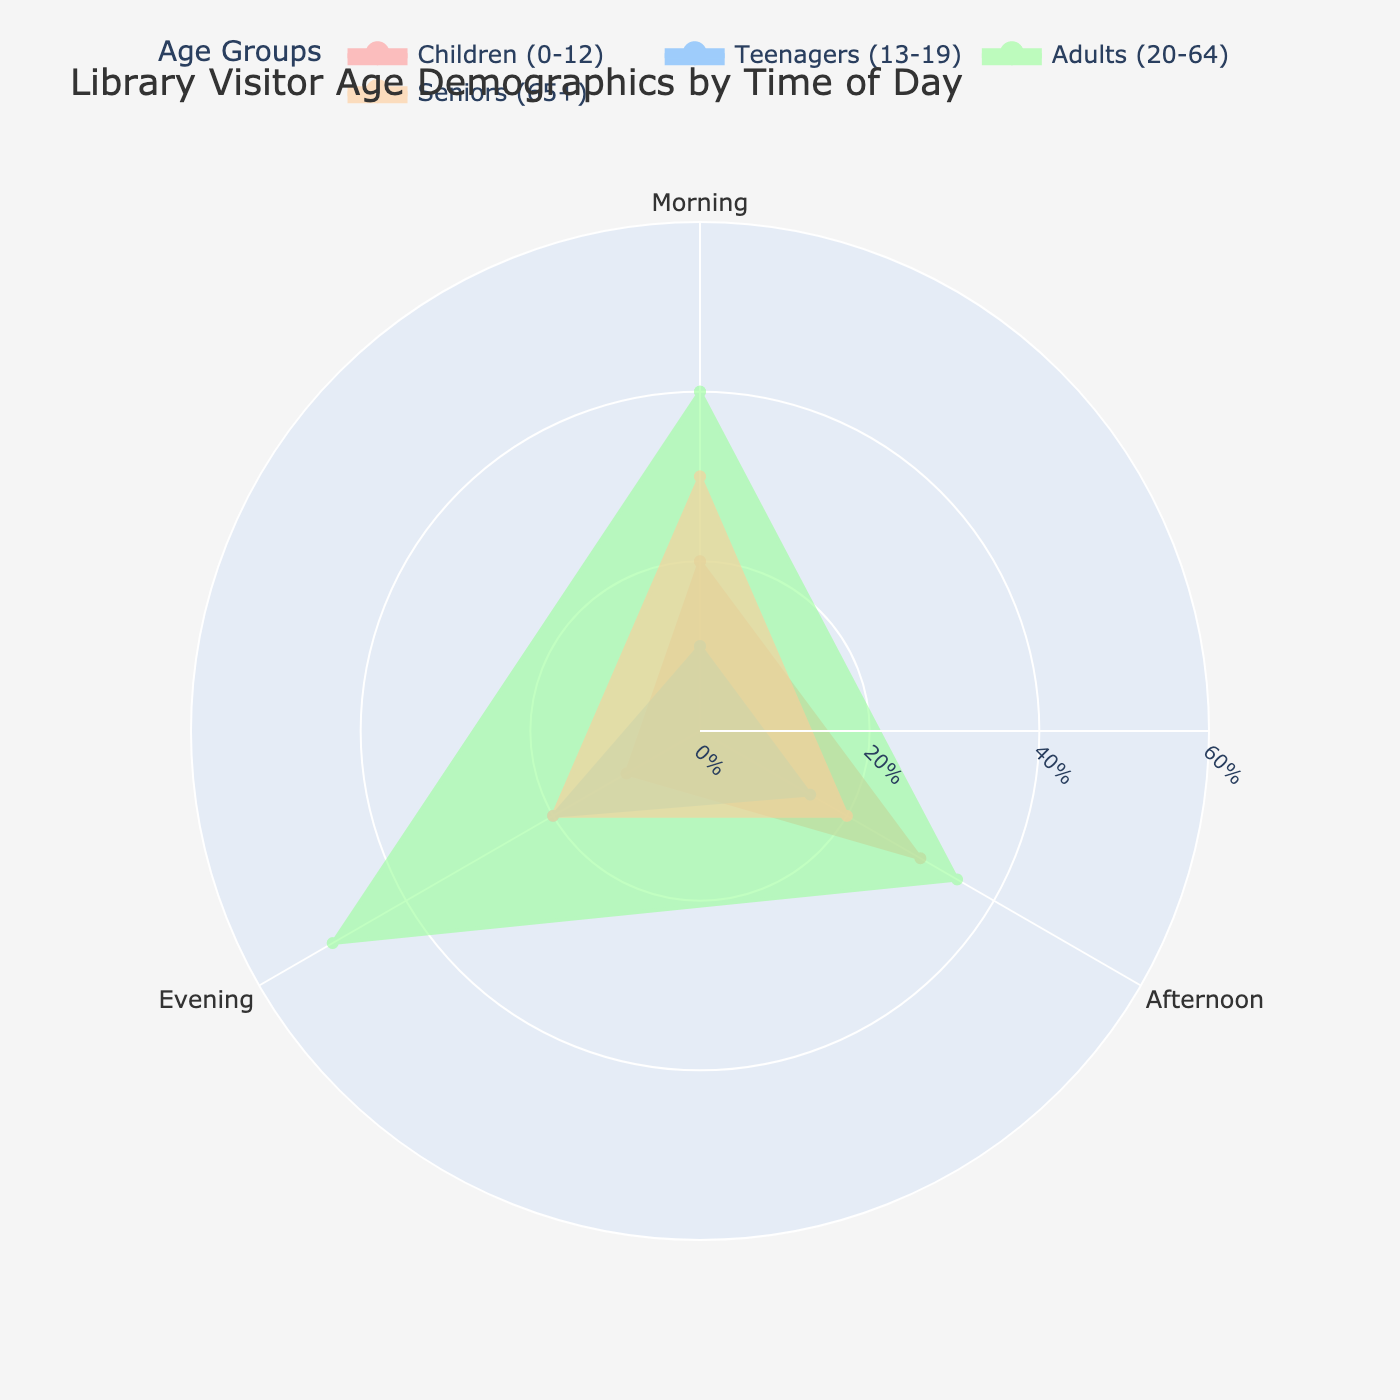What is the title of the rose chart? The title is usually found at the top of the chart and indicates what the chart is about. In this case, it states the subject of the data shown in the rose chart.
Answer: Library Visitor Age Demographics by Time of Day Which age group has the highest percentage of visitors in the evening? To find this, look at the segments for the evening and identify which age group has the largest segment. This tells us the group with the highest percentage of visitors in the evening.
Answer: Adults (20-64) What percentage of children visit the library in the afternoon? Locate the segment for children during the afternoon and read the corresponding percentage value.
Answer: 30% How does the percentage of senior visitors in the morning compare to that in the afternoon? Compare the percentage values for seniors in the morning with those in the afternoon by looking at the respective segments in the chart.
Answer: More seniors visit in the morning Which time of day sees the lowest percentage of child visitors? Observe the segments for children across different times of the day and identify the smallest segment.
Answer: Evening What is the difference in the percentage of teenage visitors between the afternoon and evening? Find the percentage of teenage visitors in both the afternoon and evening segments, then subtract the smaller value from the larger one to find the difference.
Answer: 5% Which age group has the smallest percentage of visitors in the morning? Compare the morning segments for all age groups and find the one with the smallest segment.
Answer: Teenagers (13-19) What is the median percentage of visitors for adults across all times of the day? List the percentage values for adults at all times, sort them in numerical order, and find the middle value. The percentages are 40 (morning), 35 (afternoon), and 50 (evening); hence, sorting them gives 35, 40, 50. The median is the middle value.
Answer: 40% What can be inferred about the visiting patterns of children and teenagers throughout the day? Analyze the patterns and trends shown by the segments for children and teenagers across different times of the day to make an inference about their library visiting habits.
Answer: Children visit most in the afternoon, teenagers in the evening 